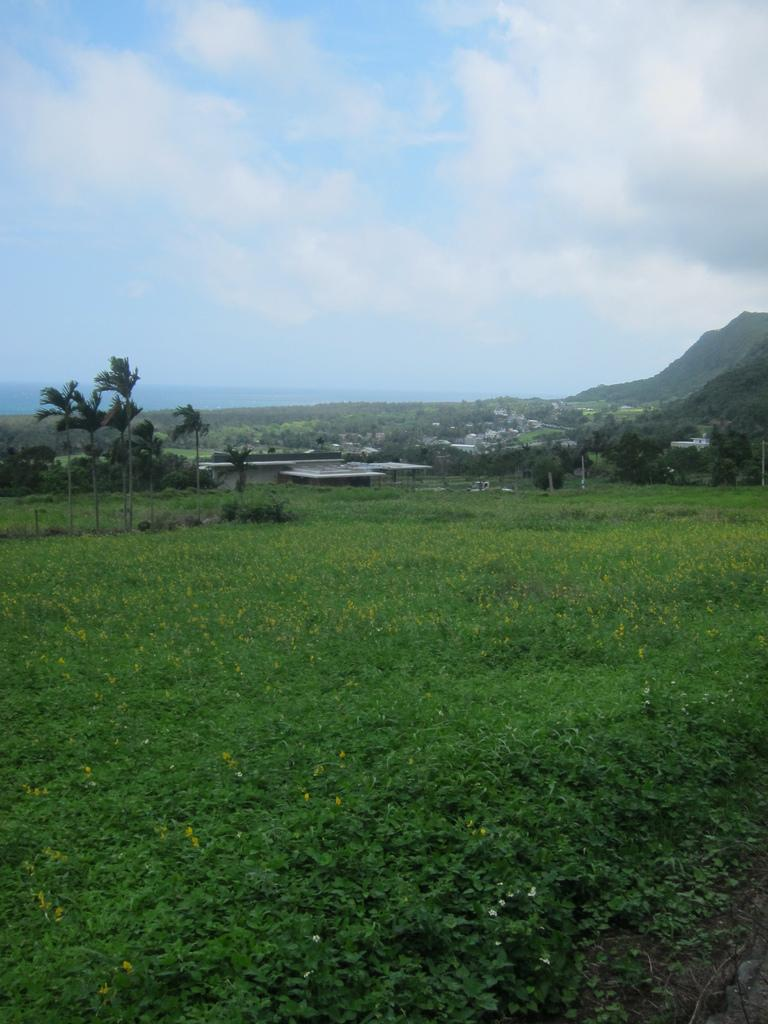What type of vegetation can be seen in the image? There are plants and trees in the image. What geographical feature is present in the image? There is a mountain in the image. What is visible in the background of the image? The sky is visible in the background of the image. What can be seen in the sky? There are clouds in the sky. Can you see a sack being pushed along the seashore in the image? There is no seashore or sack present in the image, and no pushing is depicted. 